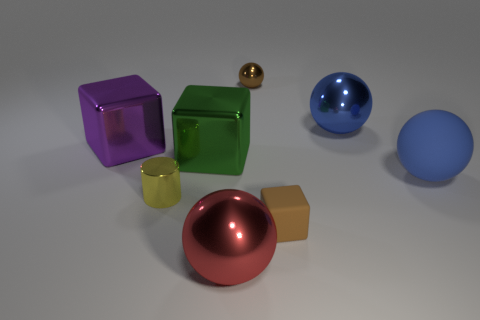Subtract all cyan balls. Subtract all green cylinders. How many balls are left? 4 Add 1 big blue matte balls. How many objects exist? 9 Subtract all blocks. How many objects are left? 5 Subtract 0 blue cylinders. How many objects are left? 8 Subtract all blue spheres. Subtract all brown balls. How many objects are left? 5 Add 8 brown spheres. How many brown spheres are left? 9 Add 7 large matte things. How many large matte things exist? 8 